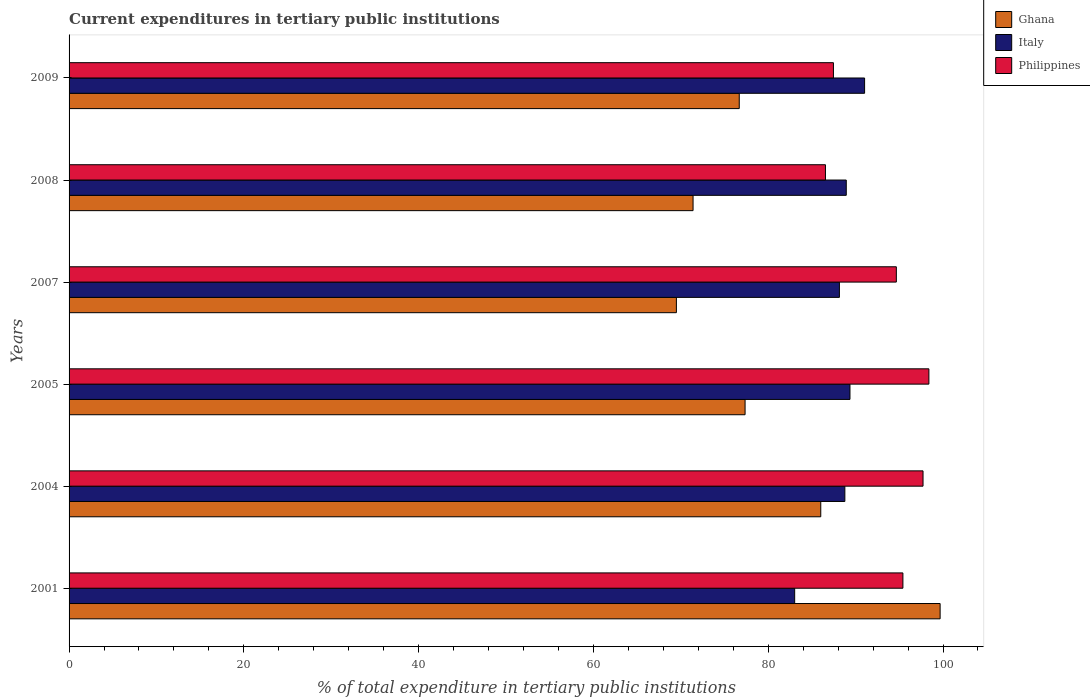How many different coloured bars are there?
Provide a short and direct response. 3. Are the number of bars per tick equal to the number of legend labels?
Provide a short and direct response. Yes. How many bars are there on the 3rd tick from the bottom?
Ensure brevity in your answer.  3. In how many cases, is the number of bars for a given year not equal to the number of legend labels?
Offer a terse response. 0. What is the current expenditures in tertiary public institutions in Philippines in 2008?
Provide a succinct answer. 86.55. Across all years, what is the maximum current expenditures in tertiary public institutions in Ghana?
Provide a succinct answer. 99.67. Across all years, what is the minimum current expenditures in tertiary public institutions in Italy?
Ensure brevity in your answer.  83.03. In which year was the current expenditures in tertiary public institutions in Philippines maximum?
Provide a short and direct response. 2005. In which year was the current expenditures in tertiary public institutions in Italy minimum?
Ensure brevity in your answer.  2001. What is the total current expenditures in tertiary public institutions in Italy in the graph?
Offer a very short reply. 529.26. What is the difference between the current expenditures in tertiary public institutions in Italy in 2001 and that in 2007?
Your response must be concise. -5.12. What is the difference between the current expenditures in tertiary public institutions in Philippines in 2004 and the current expenditures in tertiary public institutions in Ghana in 2009?
Offer a very short reply. 21.03. What is the average current expenditures in tertiary public institutions in Ghana per year?
Provide a short and direct response. 80.1. In the year 2008, what is the difference between the current expenditures in tertiary public institutions in Italy and current expenditures in tertiary public institutions in Philippines?
Keep it short and to the point. 2.38. What is the ratio of the current expenditures in tertiary public institutions in Italy in 2005 to that in 2007?
Your response must be concise. 1.01. What is the difference between the highest and the second highest current expenditures in tertiary public institutions in Ghana?
Your answer should be very brief. 13.66. What is the difference between the highest and the lowest current expenditures in tertiary public institutions in Ghana?
Provide a succinct answer. 30.18. In how many years, is the current expenditures in tertiary public institutions in Ghana greater than the average current expenditures in tertiary public institutions in Ghana taken over all years?
Give a very brief answer. 2. Is the sum of the current expenditures in tertiary public institutions in Philippines in 2007 and 2008 greater than the maximum current expenditures in tertiary public institutions in Ghana across all years?
Provide a succinct answer. Yes. Is it the case that in every year, the sum of the current expenditures in tertiary public institutions in Ghana and current expenditures in tertiary public institutions in Italy is greater than the current expenditures in tertiary public institutions in Philippines?
Keep it short and to the point. Yes. Are all the bars in the graph horizontal?
Provide a short and direct response. Yes. How many legend labels are there?
Ensure brevity in your answer.  3. How are the legend labels stacked?
Provide a succinct answer. Vertical. What is the title of the graph?
Give a very brief answer. Current expenditures in tertiary public institutions. Does "North America" appear as one of the legend labels in the graph?
Give a very brief answer. No. What is the label or title of the X-axis?
Keep it short and to the point. % of total expenditure in tertiary public institutions. What is the label or title of the Y-axis?
Offer a terse response. Years. What is the % of total expenditure in tertiary public institutions of Ghana in 2001?
Your answer should be compact. 99.67. What is the % of total expenditure in tertiary public institutions in Italy in 2001?
Your answer should be compact. 83.03. What is the % of total expenditure in tertiary public institutions in Philippines in 2001?
Your response must be concise. 95.41. What is the % of total expenditure in tertiary public institutions in Ghana in 2004?
Your answer should be compact. 86.01. What is the % of total expenditure in tertiary public institutions in Italy in 2004?
Offer a terse response. 88.77. What is the % of total expenditure in tertiary public institutions in Philippines in 2004?
Keep it short and to the point. 97.72. What is the % of total expenditure in tertiary public institutions in Ghana in 2005?
Your response must be concise. 77.35. What is the % of total expenditure in tertiary public institutions of Italy in 2005?
Provide a short and direct response. 89.36. What is the % of total expenditure in tertiary public institutions of Philippines in 2005?
Your answer should be compact. 98.39. What is the % of total expenditure in tertiary public institutions in Ghana in 2007?
Your answer should be compact. 69.49. What is the % of total expenditure in tertiary public institutions in Italy in 2007?
Ensure brevity in your answer.  88.15. What is the % of total expenditure in tertiary public institutions of Philippines in 2007?
Make the answer very short. 94.66. What is the % of total expenditure in tertiary public institutions in Ghana in 2008?
Give a very brief answer. 71.4. What is the % of total expenditure in tertiary public institutions in Italy in 2008?
Make the answer very short. 88.93. What is the % of total expenditure in tertiary public institutions of Philippines in 2008?
Keep it short and to the point. 86.55. What is the % of total expenditure in tertiary public institutions in Ghana in 2009?
Your response must be concise. 76.69. What is the % of total expenditure in tertiary public institutions of Italy in 2009?
Your answer should be very brief. 91.03. What is the % of total expenditure in tertiary public institutions in Philippines in 2009?
Your answer should be very brief. 87.46. Across all years, what is the maximum % of total expenditure in tertiary public institutions in Ghana?
Your answer should be very brief. 99.67. Across all years, what is the maximum % of total expenditure in tertiary public institutions in Italy?
Provide a short and direct response. 91.03. Across all years, what is the maximum % of total expenditure in tertiary public institutions in Philippines?
Provide a succinct answer. 98.39. Across all years, what is the minimum % of total expenditure in tertiary public institutions of Ghana?
Offer a terse response. 69.49. Across all years, what is the minimum % of total expenditure in tertiary public institutions in Italy?
Give a very brief answer. 83.03. Across all years, what is the minimum % of total expenditure in tertiary public institutions of Philippines?
Keep it short and to the point. 86.55. What is the total % of total expenditure in tertiary public institutions in Ghana in the graph?
Your answer should be compact. 480.62. What is the total % of total expenditure in tertiary public institutions in Italy in the graph?
Provide a short and direct response. 529.26. What is the total % of total expenditure in tertiary public institutions in Philippines in the graph?
Offer a very short reply. 560.19. What is the difference between the % of total expenditure in tertiary public institutions of Ghana in 2001 and that in 2004?
Keep it short and to the point. 13.66. What is the difference between the % of total expenditure in tertiary public institutions of Italy in 2001 and that in 2004?
Provide a short and direct response. -5.74. What is the difference between the % of total expenditure in tertiary public institutions of Philippines in 2001 and that in 2004?
Make the answer very short. -2.3. What is the difference between the % of total expenditure in tertiary public institutions in Ghana in 2001 and that in 2005?
Keep it short and to the point. 22.32. What is the difference between the % of total expenditure in tertiary public institutions of Italy in 2001 and that in 2005?
Offer a terse response. -6.33. What is the difference between the % of total expenditure in tertiary public institutions in Philippines in 2001 and that in 2005?
Give a very brief answer. -2.97. What is the difference between the % of total expenditure in tertiary public institutions of Ghana in 2001 and that in 2007?
Offer a terse response. 30.18. What is the difference between the % of total expenditure in tertiary public institutions in Italy in 2001 and that in 2007?
Ensure brevity in your answer.  -5.12. What is the difference between the % of total expenditure in tertiary public institutions of Philippines in 2001 and that in 2007?
Offer a terse response. 0.75. What is the difference between the % of total expenditure in tertiary public institutions in Ghana in 2001 and that in 2008?
Your answer should be very brief. 28.27. What is the difference between the % of total expenditure in tertiary public institutions of Italy in 2001 and that in 2008?
Give a very brief answer. -5.9. What is the difference between the % of total expenditure in tertiary public institutions of Philippines in 2001 and that in 2008?
Offer a very short reply. 8.86. What is the difference between the % of total expenditure in tertiary public institutions of Ghana in 2001 and that in 2009?
Your answer should be compact. 22.98. What is the difference between the % of total expenditure in tertiary public institutions in Italy in 2001 and that in 2009?
Ensure brevity in your answer.  -8. What is the difference between the % of total expenditure in tertiary public institutions in Philippines in 2001 and that in 2009?
Keep it short and to the point. 7.95. What is the difference between the % of total expenditure in tertiary public institutions in Ghana in 2004 and that in 2005?
Provide a succinct answer. 8.66. What is the difference between the % of total expenditure in tertiary public institutions of Italy in 2004 and that in 2005?
Your response must be concise. -0.59. What is the difference between the % of total expenditure in tertiary public institutions of Philippines in 2004 and that in 2005?
Give a very brief answer. -0.67. What is the difference between the % of total expenditure in tertiary public institutions of Ghana in 2004 and that in 2007?
Offer a terse response. 16.52. What is the difference between the % of total expenditure in tertiary public institutions in Italy in 2004 and that in 2007?
Provide a short and direct response. 0.62. What is the difference between the % of total expenditure in tertiary public institutions in Philippines in 2004 and that in 2007?
Ensure brevity in your answer.  3.05. What is the difference between the % of total expenditure in tertiary public institutions in Ghana in 2004 and that in 2008?
Your response must be concise. 14.61. What is the difference between the % of total expenditure in tertiary public institutions in Italy in 2004 and that in 2008?
Provide a succinct answer. -0.16. What is the difference between the % of total expenditure in tertiary public institutions of Philippines in 2004 and that in 2008?
Make the answer very short. 11.17. What is the difference between the % of total expenditure in tertiary public institutions of Ghana in 2004 and that in 2009?
Make the answer very short. 9.33. What is the difference between the % of total expenditure in tertiary public institutions of Italy in 2004 and that in 2009?
Your response must be concise. -2.26. What is the difference between the % of total expenditure in tertiary public institutions in Philippines in 2004 and that in 2009?
Your response must be concise. 10.25. What is the difference between the % of total expenditure in tertiary public institutions of Ghana in 2005 and that in 2007?
Offer a terse response. 7.86. What is the difference between the % of total expenditure in tertiary public institutions in Italy in 2005 and that in 2007?
Provide a succinct answer. 1.21. What is the difference between the % of total expenditure in tertiary public institutions in Philippines in 2005 and that in 2007?
Offer a terse response. 3.72. What is the difference between the % of total expenditure in tertiary public institutions of Ghana in 2005 and that in 2008?
Offer a very short reply. 5.95. What is the difference between the % of total expenditure in tertiary public institutions in Italy in 2005 and that in 2008?
Make the answer very short. 0.42. What is the difference between the % of total expenditure in tertiary public institutions of Philippines in 2005 and that in 2008?
Make the answer very short. 11.84. What is the difference between the % of total expenditure in tertiary public institutions of Ghana in 2005 and that in 2009?
Your answer should be very brief. 0.67. What is the difference between the % of total expenditure in tertiary public institutions of Italy in 2005 and that in 2009?
Your answer should be compact. -1.67. What is the difference between the % of total expenditure in tertiary public institutions in Philippines in 2005 and that in 2009?
Provide a short and direct response. 10.92. What is the difference between the % of total expenditure in tertiary public institutions of Ghana in 2007 and that in 2008?
Offer a very short reply. -1.91. What is the difference between the % of total expenditure in tertiary public institutions of Italy in 2007 and that in 2008?
Your response must be concise. -0.78. What is the difference between the % of total expenditure in tertiary public institutions in Philippines in 2007 and that in 2008?
Your answer should be very brief. 8.11. What is the difference between the % of total expenditure in tertiary public institutions of Ghana in 2007 and that in 2009?
Your response must be concise. -7.19. What is the difference between the % of total expenditure in tertiary public institutions of Italy in 2007 and that in 2009?
Make the answer very short. -2.88. What is the difference between the % of total expenditure in tertiary public institutions in Philippines in 2007 and that in 2009?
Provide a succinct answer. 7.2. What is the difference between the % of total expenditure in tertiary public institutions of Ghana in 2008 and that in 2009?
Your answer should be very brief. -5.29. What is the difference between the % of total expenditure in tertiary public institutions in Italy in 2008 and that in 2009?
Your answer should be very brief. -2.1. What is the difference between the % of total expenditure in tertiary public institutions of Philippines in 2008 and that in 2009?
Provide a succinct answer. -0.91. What is the difference between the % of total expenditure in tertiary public institutions in Ghana in 2001 and the % of total expenditure in tertiary public institutions in Italy in 2004?
Offer a very short reply. 10.9. What is the difference between the % of total expenditure in tertiary public institutions of Ghana in 2001 and the % of total expenditure in tertiary public institutions of Philippines in 2004?
Give a very brief answer. 1.96. What is the difference between the % of total expenditure in tertiary public institutions in Italy in 2001 and the % of total expenditure in tertiary public institutions in Philippines in 2004?
Your response must be concise. -14.69. What is the difference between the % of total expenditure in tertiary public institutions of Ghana in 2001 and the % of total expenditure in tertiary public institutions of Italy in 2005?
Keep it short and to the point. 10.32. What is the difference between the % of total expenditure in tertiary public institutions of Ghana in 2001 and the % of total expenditure in tertiary public institutions of Philippines in 2005?
Your response must be concise. 1.29. What is the difference between the % of total expenditure in tertiary public institutions in Italy in 2001 and the % of total expenditure in tertiary public institutions in Philippines in 2005?
Your response must be concise. -15.36. What is the difference between the % of total expenditure in tertiary public institutions in Ghana in 2001 and the % of total expenditure in tertiary public institutions in Italy in 2007?
Give a very brief answer. 11.52. What is the difference between the % of total expenditure in tertiary public institutions in Ghana in 2001 and the % of total expenditure in tertiary public institutions in Philippines in 2007?
Keep it short and to the point. 5.01. What is the difference between the % of total expenditure in tertiary public institutions of Italy in 2001 and the % of total expenditure in tertiary public institutions of Philippines in 2007?
Offer a terse response. -11.63. What is the difference between the % of total expenditure in tertiary public institutions of Ghana in 2001 and the % of total expenditure in tertiary public institutions of Italy in 2008?
Provide a succinct answer. 10.74. What is the difference between the % of total expenditure in tertiary public institutions of Ghana in 2001 and the % of total expenditure in tertiary public institutions of Philippines in 2008?
Your answer should be compact. 13.12. What is the difference between the % of total expenditure in tertiary public institutions in Italy in 2001 and the % of total expenditure in tertiary public institutions in Philippines in 2008?
Keep it short and to the point. -3.52. What is the difference between the % of total expenditure in tertiary public institutions of Ghana in 2001 and the % of total expenditure in tertiary public institutions of Italy in 2009?
Provide a succinct answer. 8.64. What is the difference between the % of total expenditure in tertiary public institutions in Ghana in 2001 and the % of total expenditure in tertiary public institutions in Philippines in 2009?
Give a very brief answer. 12.21. What is the difference between the % of total expenditure in tertiary public institutions of Italy in 2001 and the % of total expenditure in tertiary public institutions of Philippines in 2009?
Offer a very short reply. -4.44. What is the difference between the % of total expenditure in tertiary public institutions in Ghana in 2004 and the % of total expenditure in tertiary public institutions in Italy in 2005?
Make the answer very short. -3.34. What is the difference between the % of total expenditure in tertiary public institutions of Ghana in 2004 and the % of total expenditure in tertiary public institutions of Philippines in 2005?
Provide a succinct answer. -12.37. What is the difference between the % of total expenditure in tertiary public institutions of Italy in 2004 and the % of total expenditure in tertiary public institutions of Philippines in 2005?
Offer a very short reply. -9.62. What is the difference between the % of total expenditure in tertiary public institutions of Ghana in 2004 and the % of total expenditure in tertiary public institutions of Italy in 2007?
Your answer should be very brief. -2.13. What is the difference between the % of total expenditure in tertiary public institutions in Ghana in 2004 and the % of total expenditure in tertiary public institutions in Philippines in 2007?
Provide a short and direct response. -8.65. What is the difference between the % of total expenditure in tertiary public institutions of Italy in 2004 and the % of total expenditure in tertiary public institutions of Philippines in 2007?
Keep it short and to the point. -5.89. What is the difference between the % of total expenditure in tertiary public institutions of Ghana in 2004 and the % of total expenditure in tertiary public institutions of Italy in 2008?
Your response must be concise. -2.92. What is the difference between the % of total expenditure in tertiary public institutions of Ghana in 2004 and the % of total expenditure in tertiary public institutions of Philippines in 2008?
Offer a terse response. -0.54. What is the difference between the % of total expenditure in tertiary public institutions of Italy in 2004 and the % of total expenditure in tertiary public institutions of Philippines in 2008?
Offer a terse response. 2.22. What is the difference between the % of total expenditure in tertiary public institutions in Ghana in 2004 and the % of total expenditure in tertiary public institutions in Italy in 2009?
Keep it short and to the point. -5.01. What is the difference between the % of total expenditure in tertiary public institutions of Ghana in 2004 and the % of total expenditure in tertiary public institutions of Philippines in 2009?
Offer a terse response. -1.45. What is the difference between the % of total expenditure in tertiary public institutions of Italy in 2004 and the % of total expenditure in tertiary public institutions of Philippines in 2009?
Give a very brief answer. 1.31. What is the difference between the % of total expenditure in tertiary public institutions of Ghana in 2005 and the % of total expenditure in tertiary public institutions of Italy in 2007?
Your answer should be very brief. -10.79. What is the difference between the % of total expenditure in tertiary public institutions in Ghana in 2005 and the % of total expenditure in tertiary public institutions in Philippines in 2007?
Ensure brevity in your answer.  -17.31. What is the difference between the % of total expenditure in tertiary public institutions of Italy in 2005 and the % of total expenditure in tertiary public institutions of Philippines in 2007?
Your answer should be compact. -5.31. What is the difference between the % of total expenditure in tertiary public institutions in Ghana in 2005 and the % of total expenditure in tertiary public institutions in Italy in 2008?
Keep it short and to the point. -11.58. What is the difference between the % of total expenditure in tertiary public institutions in Ghana in 2005 and the % of total expenditure in tertiary public institutions in Philippines in 2008?
Your answer should be very brief. -9.2. What is the difference between the % of total expenditure in tertiary public institutions in Italy in 2005 and the % of total expenditure in tertiary public institutions in Philippines in 2008?
Make the answer very short. 2.81. What is the difference between the % of total expenditure in tertiary public institutions in Ghana in 2005 and the % of total expenditure in tertiary public institutions in Italy in 2009?
Provide a succinct answer. -13.68. What is the difference between the % of total expenditure in tertiary public institutions in Ghana in 2005 and the % of total expenditure in tertiary public institutions in Philippines in 2009?
Keep it short and to the point. -10.11. What is the difference between the % of total expenditure in tertiary public institutions in Italy in 2005 and the % of total expenditure in tertiary public institutions in Philippines in 2009?
Keep it short and to the point. 1.89. What is the difference between the % of total expenditure in tertiary public institutions of Ghana in 2007 and the % of total expenditure in tertiary public institutions of Italy in 2008?
Your answer should be very brief. -19.44. What is the difference between the % of total expenditure in tertiary public institutions of Ghana in 2007 and the % of total expenditure in tertiary public institutions of Philippines in 2008?
Provide a succinct answer. -17.06. What is the difference between the % of total expenditure in tertiary public institutions of Italy in 2007 and the % of total expenditure in tertiary public institutions of Philippines in 2008?
Offer a very short reply. 1.6. What is the difference between the % of total expenditure in tertiary public institutions in Ghana in 2007 and the % of total expenditure in tertiary public institutions in Italy in 2009?
Your answer should be very brief. -21.53. What is the difference between the % of total expenditure in tertiary public institutions in Ghana in 2007 and the % of total expenditure in tertiary public institutions in Philippines in 2009?
Provide a short and direct response. -17.97. What is the difference between the % of total expenditure in tertiary public institutions of Italy in 2007 and the % of total expenditure in tertiary public institutions of Philippines in 2009?
Provide a short and direct response. 0.68. What is the difference between the % of total expenditure in tertiary public institutions in Ghana in 2008 and the % of total expenditure in tertiary public institutions in Italy in 2009?
Keep it short and to the point. -19.63. What is the difference between the % of total expenditure in tertiary public institutions of Ghana in 2008 and the % of total expenditure in tertiary public institutions of Philippines in 2009?
Give a very brief answer. -16.06. What is the difference between the % of total expenditure in tertiary public institutions of Italy in 2008 and the % of total expenditure in tertiary public institutions of Philippines in 2009?
Make the answer very short. 1.47. What is the average % of total expenditure in tertiary public institutions in Ghana per year?
Make the answer very short. 80.1. What is the average % of total expenditure in tertiary public institutions in Italy per year?
Ensure brevity in your answer.  88.21. What is the average % of total expenditure in tertiary public institutions of Philippines per year?
Make the answer very short. 93.36. In the year 2001, what is the difference between the % of total expenditure in tertiary public institutions in Ghana and % of total expenditure in tertiary public institutions in Italy?
Make the answer very short. 16.64. In the year 2001, what is the difference between the % of total expenditure in tertiary public institutions of Ghana and % of total expenditure in tertiary public institutions of Philippines?
Provide a succinct answer. 4.26. In the year 2001, what is the difference between the % of total expenditure in tertiary public institutions in Italy and % of total expenditure in tertiary public institutions in Philippines?
Your response must be concise. -12.39. In the year 2004, what is the difference between the % of total expenditure in tertiary public institutions of Ghana and % of total expenditure in tertiary public institutions of Italy?
Your answer should be compact. -2.76. In the year 2004, what is the difference between the % of total expenditure in tertiary public institutions in Ghana and % of total expenditure in tertiary public institutions in Philippines?
Provide a succinct answer. -11.7. In the year 2004, what is the difference between the % of total expenditure in tertiary public institutions of Italy and % of total expenditure in tertiary public institutions of Philippines?
Make the answer very short. -8.94. In the year 2005, what is the difference between the % of total expenditure in tertiary public institutions in Ghana and % of total expenditure in tertiary public institutions in Italy?
Your response must be concise. -12. In the year 2005, what is the difference between the % of total expenditure in tertiary public institutions of Ghana and % of total expenditure in tertiary public institutions of Philippines?
Offer a terse response. -21.03. In the year 2005, what is the difference between the % of total expenditure in tertiary public institutions in Italy and % of total expenditure in tertiary public institutions in Philippines?
Your answer should be very brief. -9.03. In the year 2007, what is the difference between the % of total expenditure in tertiary public institutions in Ghana and % of total expenditure in tertiary public institutions in Italy?
Offer a terse response. -18.65. In the year 2007, what is the difference between the % of total expenditure in tertiary public institutions in Ghana and % of total expenditure in tertiary public institutions in Philippines?
Your response must be concise. -25.17. In the year 2007, what is the difference between the % of total expenditure in tertiary public institutions in Italy and % of total expenditure in tertiary public institutions in Philippines?
Offer a very short reply. -6.51. In the year 2008, what is the difference between the % of total expenditure in tertiary public institutions of Ghana and % of total expenditure in tertiary public institutions of Italy?
Provide a short and direct response. -17.53. In the year 2008, what is the difference between the % of total expenditure in tertiary public institutions of Ghana and % of total expenditure in tertiary public institutions of Philippines?
Offer a terse response. -15.15. In the year 2008, what is the difference between the % of total expenditure in tertiary public institutions in Italy and % of total expenditure in tertiary public institutions in Philippines?
Provide a succinct answer. 2.38. In the year 2009, what is the difference between the % of total expenditure in tertiary public institutions in Ghana and % of total expenditure in tertiary public institutions in Italy?
Ensure brevity in your answer.  -14.34. In the year 2009, what is the difference between the % of total expenditure in tertiary public institutions in Ghana and % of total expenditure in tertiary public institutions in Philippines?
Make the answer very short. -10.78. In the year 2009, what is the difference between the % of total expenditure in tertiary public institutions in Italy and % of total expenditure in tertiary public institutions in Philippines?
Provide a short and direct response. 3.56. What is the ratio of the % of total expenditure in tertiary public institutions of Ghana in 2001 to that in 2004?
Offer a terse response. 1.16. What is the ratio of the % of total expenditure in tertiary public institutions of Italy in 2001 to that in 2004?
Your response must be concise. 0.94. What is the ratio of the % of total expenditure in tertiary public institutions of Philippines in 2001 to that in 2004?
Make the answer very short. 0.98. What is the ratio of the % of total expenditure in tertiary public institutions in Ghana in 2001 to that in 2005?
Ensure brevity in your answer.  1.29. What is the ratio of the % of total expenditure in tertiary public institutions in Italy in 2001 to that in 2005?
Keep it short and to the point. 0.93. What is the ratio of the % of total expenditure in tertiary public institutions in Philippines in 2001 to that in 2005?
Your answer should be compact. 0.97. What is the ratio of the % of total expenditure in tertiary public institutions in Ghana in 2001 to that in 2007?
Keep it short and to the point. 1.43. What is the ratio of the % of total expenditure in tertiary public institutions in Italy in 2001 to that in 2007?
Make the answer very short. 0.94. What is the ratio of the % of total expenditure in tertiary public institutions of Philippines in 2001 to that in 2007?
Your answer should be compact. 1.01. What is the ratio of the % of total expenditure in tertiary public institutions in Ghana in 2001 to that in 2008?
Offer a terse response. 1.4. What is the ratio of the % of total expenditure in tertiary public institutions in Italy in 2001 to that in 2008?
Provide a succinct answer. 0.93. What is the ratio of the % of total expenditure in tertiary public institutions in Philippines in 2001 to that in 2008?
Your answer should be compact. 1.1. What is the ratio of the % of total expenditure in tertiary public institutions in Ghana in 2001 to that in 2009?
Give a very brief answer. 1.3. What is the ratio of the % of total expenditure in tertiary public institutions of Italy in 2001 to that in 2009?
Ensure brevity in your answer.  0.91. What is the ratio of the % of total expenditure in tertiary public institutions in Philippines in 2001 to that in 2009?
Your answer should be compact. 1.09. What is the ratio of the % of total expenditure in tertiary public institutions of Ghana in 2004 to that in 2005?
Give a very brief answer. 1.11. What is the ratio of the % of total expenditure in tertiary public institutions in Italy in 2004 to that in 2005?
Offer a very short reply. 0.99. What is the ratio of the % of total expenditure in tertiary public institutions of Philippines in 2004 to that in 2005?
Offer a terse response. 0.99. What is the ratio of the % of total expenditure in tertiary public institutions in Ghana in 2004 to that in 2007?
Give a very brief answer. 1.24. What is the ratio of the % of total expenditure in tertiary public institutions of Italy in 2004 to that in 2007?
Ensure brevity in your answer.  1.01. What is the ratio of the % of total expenditure in tertiary public institutions of Philippines in 2004 to that in 2007?
Your answer should be compact. 1.03. What is the ratio of the % of total expenditure in tertiary public institutions of Ghana in 2004 to that in 2008?
Offer a very short reply. 1.2. What is the ratio of the % of total expenditure in tertiary public institutions of Philippines in 2004 to that in 2008?
Your answer should be very brief. 1.13. What is the ratio of the % of total expenditure in tertiary public institutions of Ghana in 2004 to that in 2009?
Keep it short and to the point. 1.12. What is the ratio of the % of total expenditure in tertiary public institutions in Italy in 2004 to that in 2009?
Provide a short and direct response. 0.98. What is the ratio of the % of total expenditure in tertiary public institutions in Philippines in 2004 to that in 2009?
Your response must be concise. 1.12. What is the ratio of the % of total expenditure in tertiary public institutions of Ghana in 2005 to that in 2007?
Ensure brevity in your answer.  1.11. What is the ratio of the % of total expenditure in tertiary public institutions in Italy in 2005 to that in 2007?
Give a very brief answer. 1.01. What is the ratio of the % of total expenditure in tertiary public institutions of Philippines in 2005 to that in 2007?
Your answer should be very brief. 1.04. What is the ratio of the % of total expenditure in tertiary public institutions in Ghana in 2005 to that in 2008?
Keep it short and to the point. 1.08. What is the ratio of the % of total expenditure in tertiary public institutions of Italy in 2005 to that in 2008?
Ensure brevity in your answer.  1. What is the ratio of the % of total expenditure in tertiary public institutions in Philippines in 2005 to that in 2008?
Offer a very short reply. 1.14. What is the ratio of the % of total expenditure in tertiary public institutions of Ghana in 2005 to that in 2009?
Give a very brief answer. 1.01. What is the ratio of the % of total expenditure in tertiary public institutions of Italy in 2005 to that in 2009?
Your answer should be compact. 0.98. What is the ratio of the % of total expenditure in tertiary public institutions of Philippines in 2005 to that in 2009?
Ensure brevity in your answer.  1.12. What is the ratio of the % of total expenditure in tertiary public institutions of Ghana in 2007 to that in 2008?
Your answer should be very brief. 0.97. What is the ratio of the % of total expenditure in tertiary public institutions in Italy in 2007 to that in 2008?
Keep it short and to the point. 0.99. What is the ratio of the % of total expenditure in tertiary public institutions in Philippines in 2007 to that in 2008?
Provide a succinct answer. 1.09. What is the ratio of the % of total expenditure in tertiary public institutions in Ghana in 2007 to that in 2009?
Provide a succinct answer. 0.91. What is the ratio of the % of total expenditure in tertiary public institutions in Italy in 2007 to that in 2009?
Keep it short and to the point. 0.97. What is the ratio of the % of total expenditure in tertiary public institutions of Philippines in 2007 to that in 2009?
Provide a succinct answer. 1.08. What is the ratio of the % of total expenditure in tertiary public institutions in Ghana in 2008 to that in 2009?
Your answer should be compact. 0.93. What is the ratio of the % of total expenditure in tertiary public institutions in Italy in 2008 to that in 2009?
Your answer should be very brief. 0.98. What is the difference between the highest and the second highest % of total expenditure in tertiary public institutions in Ghana?
Provide a short and direct response. 13.66. What is the difference between the highest and the second highest % of total expenditure in tertiary public institutions of Italy?
Give a very brief answer. 1.67. What is the difference between the highest and the second highest % of total expenditure in tertiary public institutions in Philippines?
Keep it short and to the point. 0.67. What is the difference between the highest and the lowest % of total expenditure in tertiary public institutions of Ghana?
Your response must be concise. 30.18. What is the difference between the highest and the lowest % of total expenditure in tertiary public institutions in Italy?
Give a very brief answer. 8. What is the difference between the highest and the lowest % of total expenditure in tertiary public institutions of Philippines?
Give a very brief answer. 11.84. 